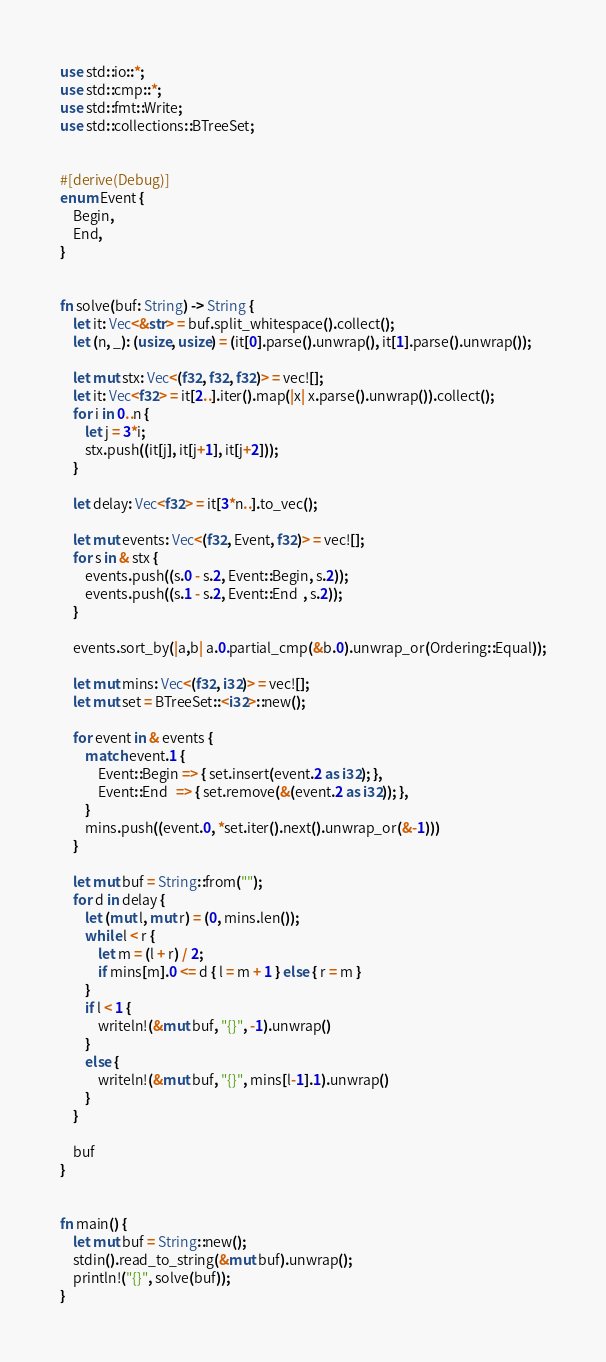Convert code to text. <code><loc_0><loc_0><loc_500><loc_500><_Rust_>use std::io::*;
use std::cmp::*;
use std::fmt::Write;
use std::collections::BTreeSet;


#[derive(Debug)]
enum Event {
    Begin,
    End,
}


fn solve(buf: String) -> String {
    let it: Vec<&str> = buf.split_whitespace().collect();
    let (n, _): (usize, usize) = (it[0].parse().unwrap(), it[1].parse().unwrap());

    let mut stx: Vec<(f32, f32, f32)> = vec![];
    let it: Vec<f32> = it[2..].iter().map(|x| x.parse().unwrap()).collect();
    for i in 0..n {
        let j = 3*i;
        stx.push((it[j], it[j+1], it[j+2]));
    }

    let delay: Vec<f32> = it[3*n..].to_vec();

    let mut events: Vec<(f32, Event, f32)> = vec![];
    for s in & stx {
        events.push((s.0 - s.2, Event::Begin, s.2));
        events.push((s.1 - s.2, Event::End  , s.2));
    }

    events.sort_by(|a,b| a.0.partial_cmp(&b.0).unwrap_or(Ordering::Equal));

    let mut mins: Vec<(f32, i32)> = vec![];
    let mut set = BTreeSet::<i32>::new();

    for event in & events {
        match event.1 {
            Event::Begin => { set.insert(event.2 as i32); },
            Event::End   => { set.remove(&(event.2 as i32)); },
        }
        mins.push((event.0, *set.iter().next().unwrap_or(&-1)))
    }

    let mut buf = String::from("");
    for d in delay {
        let (mut l, mut r) = (0, mins.len());
        while l < r {
            let m = (l + r) / 2;
            if mins[m].0 <= d { l = m + 1 } else { r = m }
        }
        if l < 1 {
            writeln!(&mut buf, "{}", -1).unwrap()
        }
        else {
            writeln!(&mut buf, "{}", mins[l-1].1).unwrap()
        }
    }

    buf
}


fn main() {
    let mut buf = String::new();
    stdin().read_to_string(&mut buf).unwrap();
    println!("{}", solve(buf));
}</code> 